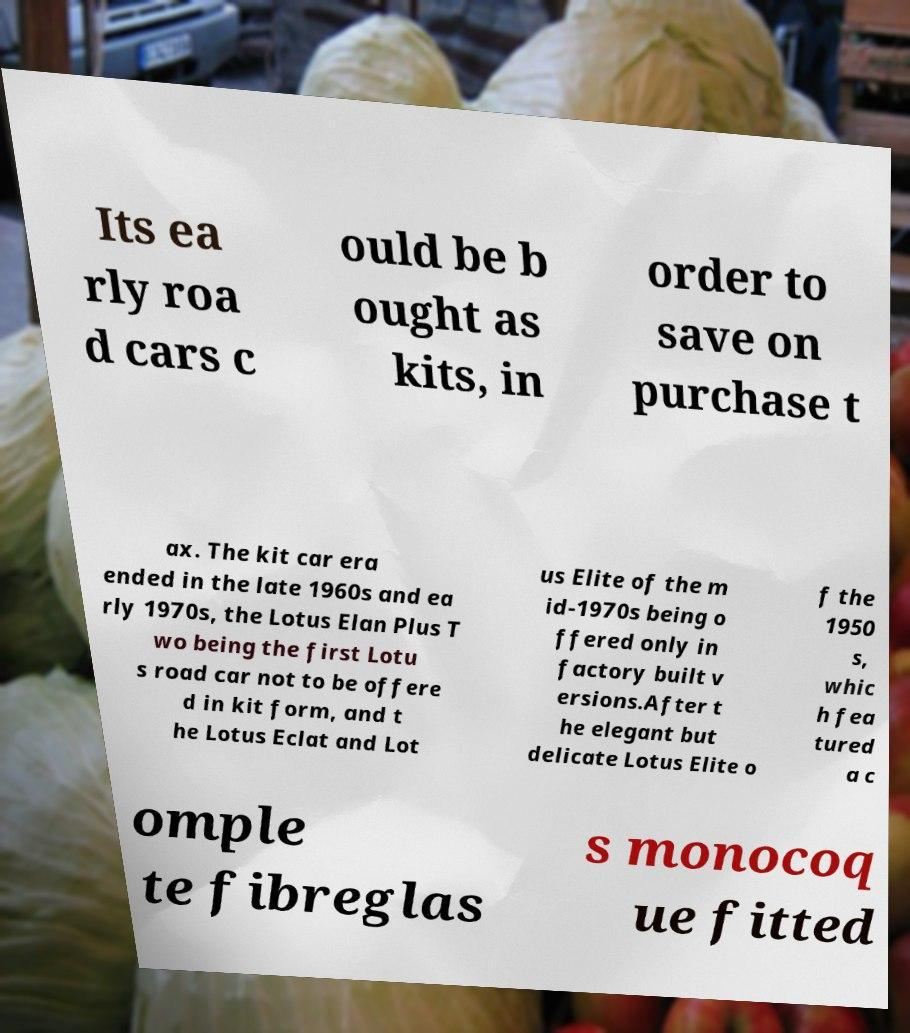For documentation purposes, I need the text within this image transcribed. Could you provide that? Its ea rly roa d cars c ould be b ought as kits, in order to save on purchase t ax. The kit car era ended in the late 1960s and ea rly 1970s, the Lotus Elan Plus T wo being the first Lotu s road car not to be offere d in kit form, and t he Lotus Eclat and Lot us Elite of the m id-1970s being o ffered only in factory built v ersions.After t he elegant but delicate Lotus Elite o f the 1950 s, whic h fea tured a c omple te fibreglas s monocoq ue fitted 